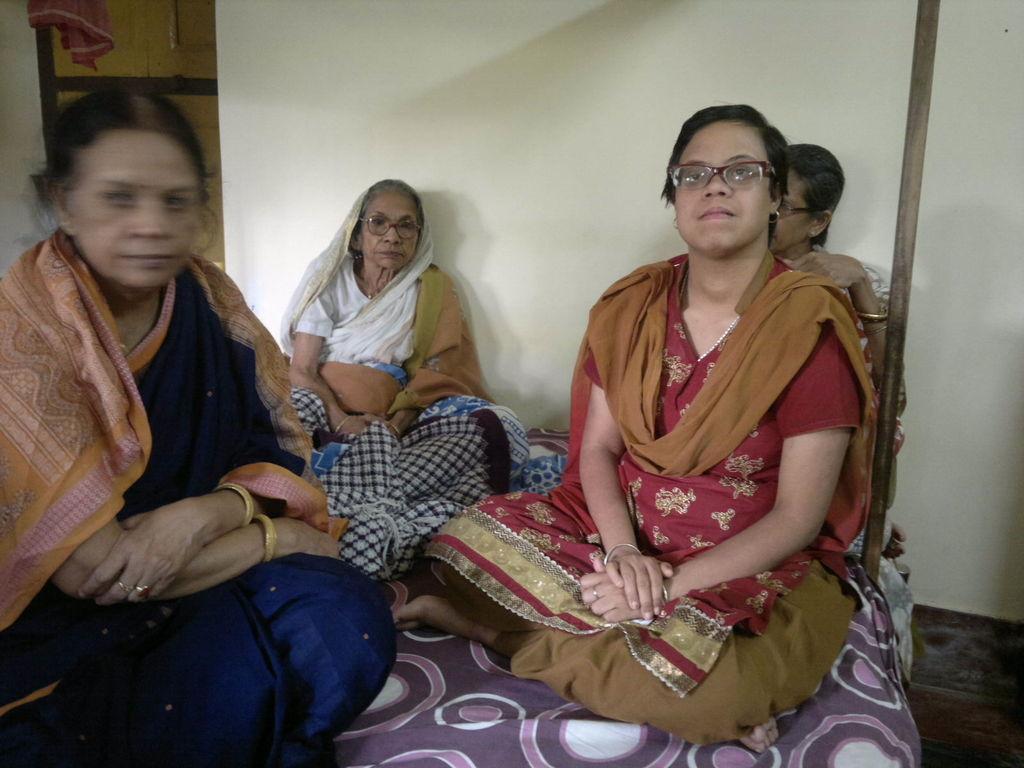Could you give a brief overview of what you see in this image? In the image in the center, we can see four people are sitting on the bed. In the background there is a wall, door, cloth etc. 